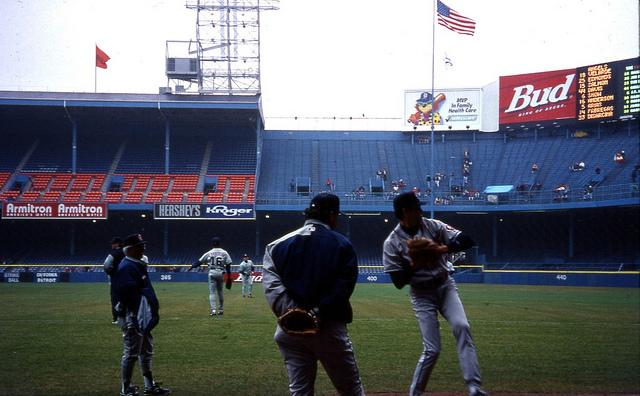Which advertiser is a watch company? Please explain your reasoning. armitron. Armitron is a watchmaker. 